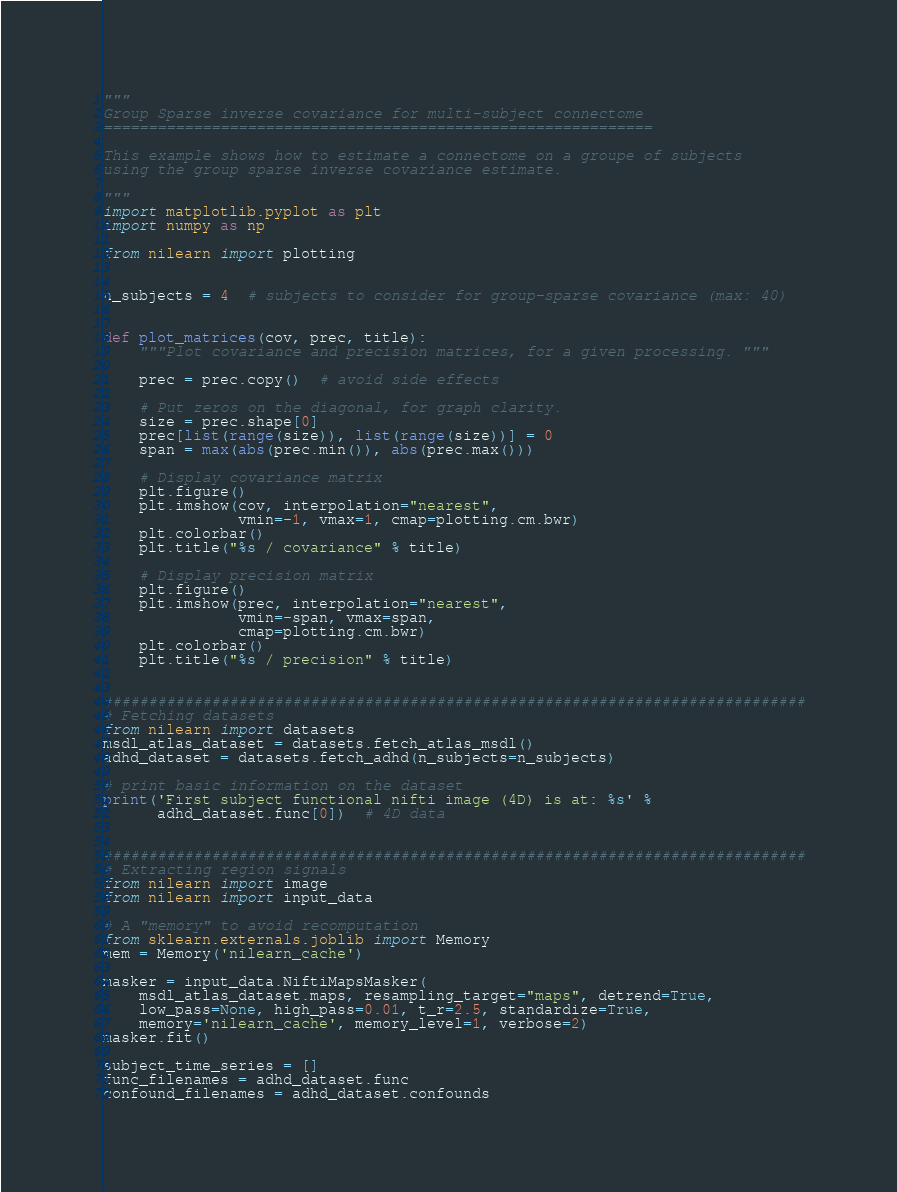Convert code to text. <code><loc_0><loc_0><loc_500><loc_500><_Python_>"""
Group Sparse inverse covariance for multi-subject connectome
=============================================================

This example shows how to estimate a connectome on a groupe of subjects
using the group sparse inverse covariance estimate.

"""
import matplotlib.pyplot as plt
import numpy as np

from nilearn import plotting


n_subjects = 4  # subjects to consider for group-sparse covariance (max: 40)


def plot_matrices(cov, prec, title):
    """Plot covariance and precision matrices, for a given processing. """

    prec = prec.copy()  # avoid side effects

    # Put zeros on the diagonal, for graph clarity.
    size = prec.shape[0]
    prec[list(range(size)), list(range(size))] = 0
    span = max(abs(prec.min()), abs(prec.max()))

    # Display covariance matrix
    plt.figure()
    plt.imshow(cov, interpolation="nearest",
               vmin=-1, vmax=1, cmap=plotting.cm.bwr)
    plt.colorbar()
    plt.title("%s / covariance" % title)

    # Display precision matrix
    plt.figure()
    plt.imshow(prec, interpolation="nearest",
               vmin=-span, vmax=span,
               cmap=plotting.cm.bwr)
    plt.colorbar()
    plt.title("%s / precision" % title)


##############################################################################
# Fetching datasets
from nilearn import datasets
msdl_atlas_dataset = datasets.fetch_atlas_msdl()
adhd_dataset = datasets.fetch_adhd(n_subjects=n_subjects)

# print basic information on the dataset
print('First subject functional nifti image (4D) is at: %s' %
      adhd_dataset.func[0])  # 4D data


##############################################################################
# Extracting region signals
from nilearn import image
from nilearn import input_data

# A "memory" to avoid recomputation
from sklearn.externals.joblib import Memory
mem = Memory('nilearn_cache')

masker = input_data.NiftiMapsMasker(
    msdl_atlas_dataset.maps, resampling_target="maps", detrend=True,
    low_pass=None, high_pass=0.01, t_r=2.5, standardize=True,
    memory='nilearn_cache', memory_level=1, verbose=2)
masker.fit()

subject_time_series = []
func_filenames = adhd_dataset.func
confound_filenames = adhd_dataset.confounds</code> 